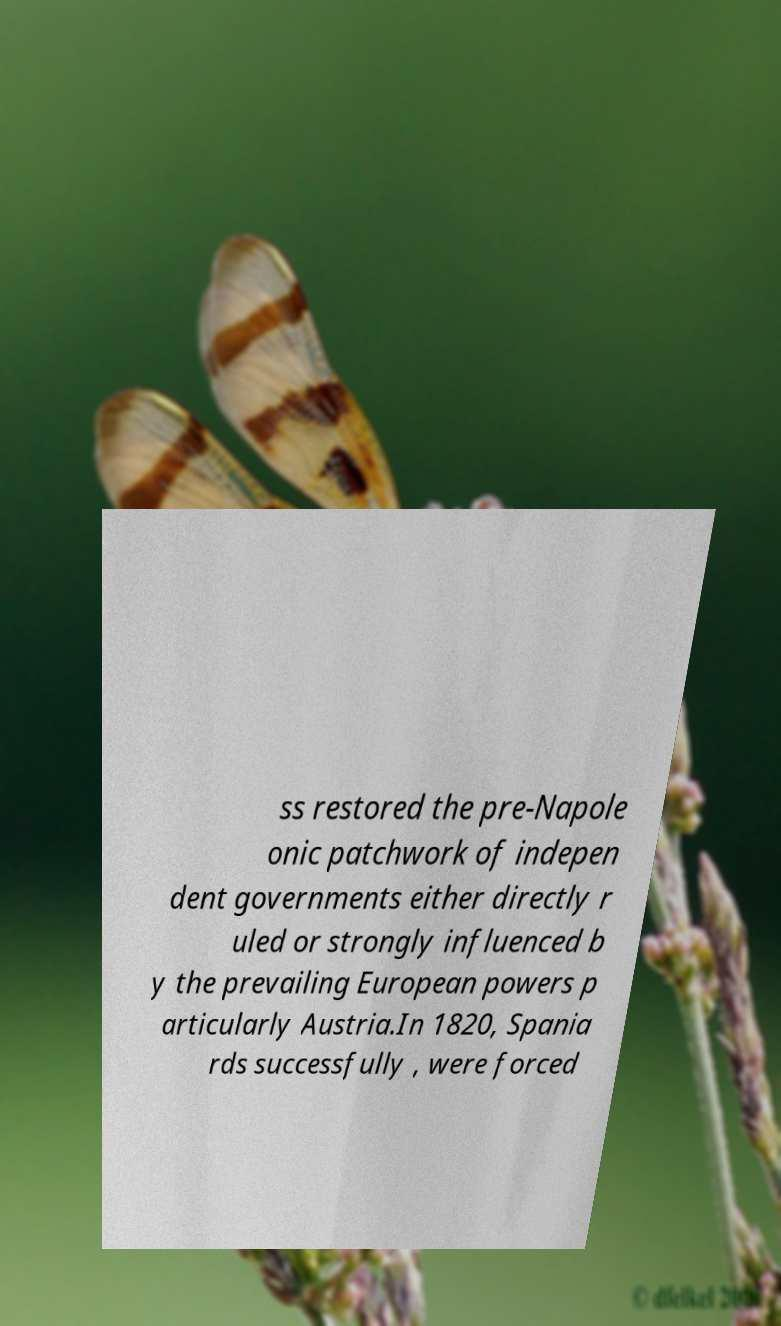Could you assist in decoding the text presented in this image and type it out clearly? ss restored the pre-Napole onic patchwork of indepen dent governments either directly r uled or strongly influenced b y the prevailing European powers p articularly Austria.In 1820, Spania rds successfully , were forced 